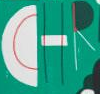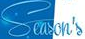Identify the words shown in these images in order, separated by a semicolon. CHR; Season's 